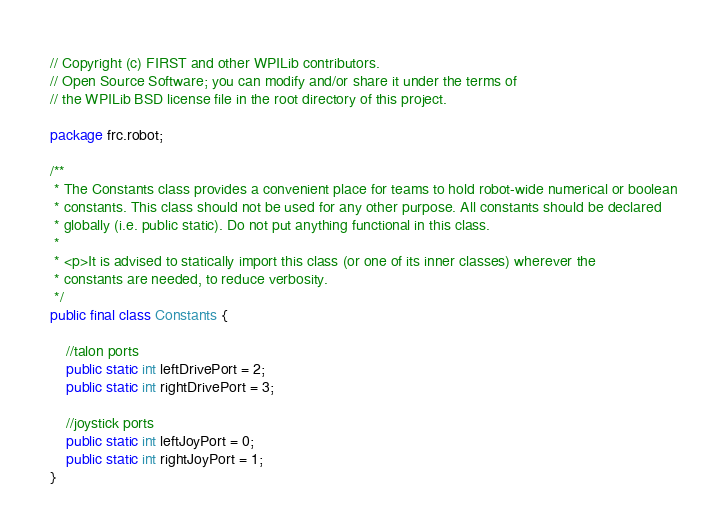Convert code to text. <code><loc_0><loc_0><loc_500><loc_500><_Java_>// Copyright (c) FIRST and other WPILib contributors.
// Open Source Software; you can modify and/or share it under the terms of
// the WPILib BSD license file in the root directory of this project.

package frc.robot;

/**
 * The Constants class provides a convenient place for teams to hold robot-wide numerical or boolean
 * constants. This class should not be used for any other purpose. All constants should be declared
 * globally (i.e. public static). Do not put anything functional in this class.
 *
 * <p>It is advised to statically import this class (or one of its inner classes) wherever the
 * constants are needed, to reduce verbosity.
 */
public final class Constants {

    //talon ports
    public static int leftDrivePort = 2;
    public static int rightDrivePort = 3;

    //joystick ports
    public static int leftJoyPort = 0;
    public static int rightJoyPort = 1;
}
</code> 